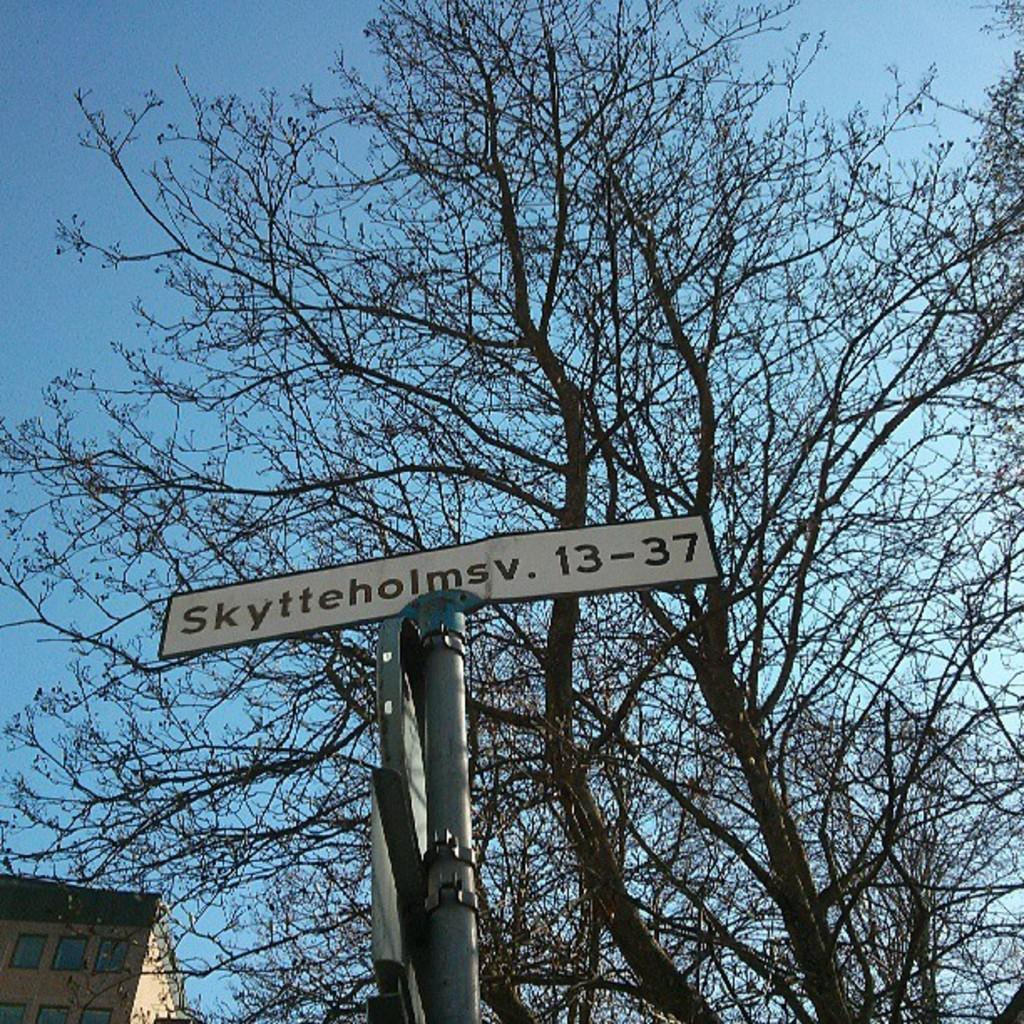What type of vegetation is present in the image? There are trees in the image. What object can be seen standing upright in the image? There is a pole in the image. What flat, rectangular object is visible in the image? There is a board in the image. What type of structure is located on the left side of the image? There is a building on the left side of the image. What part of the natural environment is visible in the background of the image? The sky is visible in the background of the image. Can you see any icicles hanging from the trees in the image? There are no icicles present in the image; it appears to be a regular day with trees and a pole. Is there a self-portrait of the photographer in the image? There is no self-portrait or any indication of the photographer's presence in the image. 